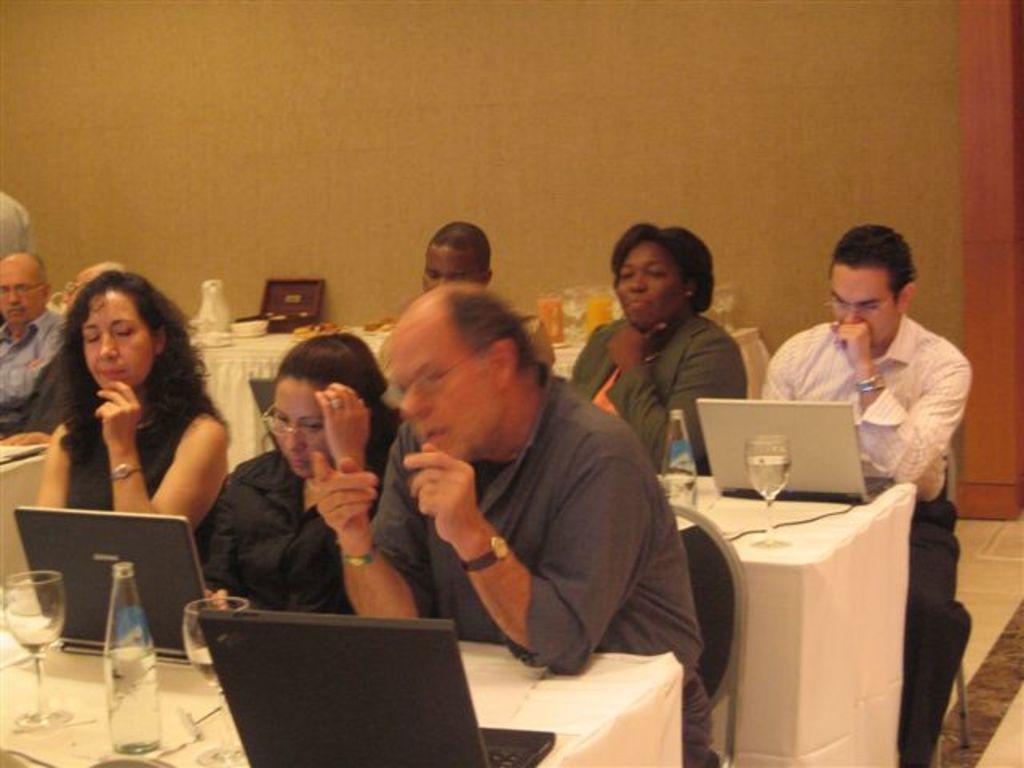How would you summarize this image in a sentence or two? in the picture there are many people sitting on a chair with a table in front of them on the table there are laptops in which they are working on the table there are bottles and glasses. 